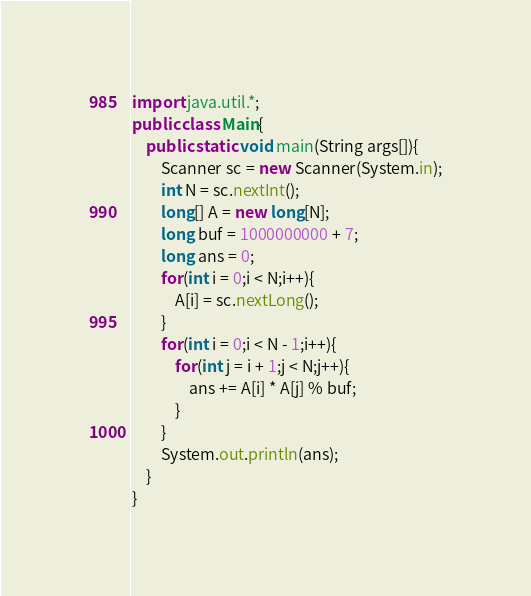Convert code to text. <code><loc_0><loc_0><loc_500><loc_500><_Java_>import java.util.*;
public class Main{
	public static void main(String args[]){
		Scanner sc = new Scanner(System.in);
		int N = sc.nextInt();
		long[] A = new long[N];
		long buf = 1000000000 + 7;
		long ans = 0;
		for(int i = 0;i < N;i++){
			A[i] = sc.nextLong();
		}
		for(int i = 0;i < N - 1;i++){
			for(int j = i + 1;j < N;j++){
				ans += A[i] * A[j] % buf;
			}
		}
		System.out.println(ans);
	}
}</code> 